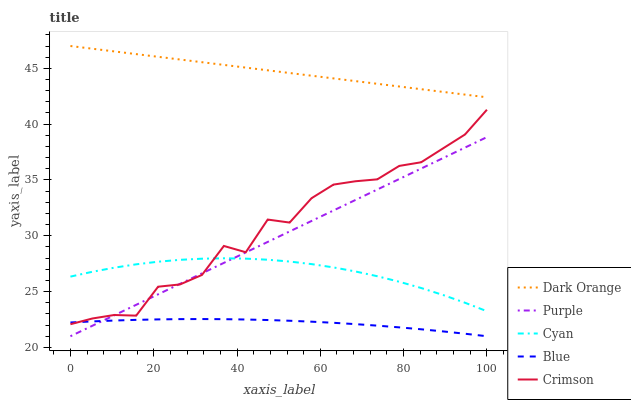Does Blue have the minimum area under the curve?
Answer yes or no. Yes. Does Dark Orange have the maximum area under the curve?
Answer yes or no. Yes. Does Crimson have the minimum area under the curve?
Answer yes or no. No. Does Crimson have the maximum area under the curve?
Answer yes or no. No. Is Purple the smoothest?
Answer yes or no. Yes. Is Crimson the roughest?
Answer yes or no. Yes. Is Dark Orange the smoothest?
Answer yes or no. No. Is Dark Orange the roughest?
Answer yes or no. No. Does Purple have the lowest value?
Answer yes or no. Yes. Does Crimson have the lowest value?
Answer yes or no. No. Does Dark Orange have the highest value?
Answer yes or no. Yes. Does Crimson have the highest value?
Answer yes or no. No. Is Purple less than Dark Orange?
Answer yes or no. Yes. Is Dark Orange greater than Purple?
Answer yes or no. Yes. Does Crimson intersect Cyan?
Answer yes or no. Yes. Is Crimson less than Cyan?
Answer yes or no. No. Is Crimson greater than Cyan?
Answer yes or no. No. Does Purple intersect Dark Orange?
Answer yes or no. No. 